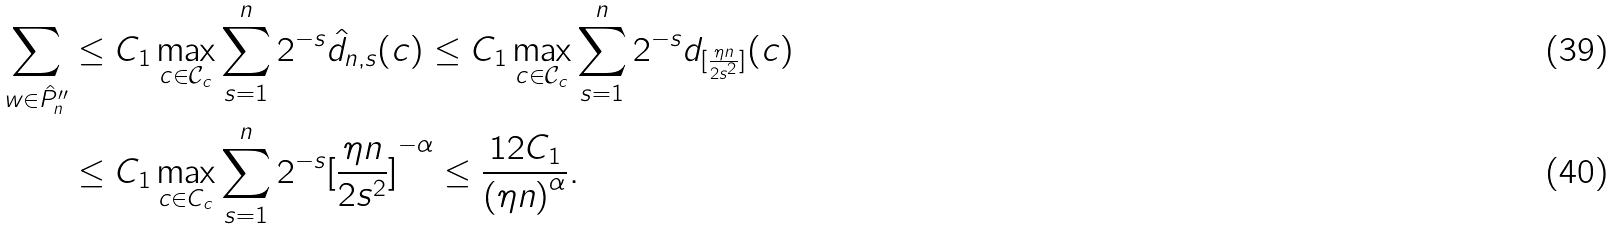<formula> <loc_0><loc_0><loc_500><loc_500>\sum _ { w \in \hat { P } _ { n } ^ { \prime \prime } } & \leq C _ { 1 } \max _ { c \in \mathcal { C } _ { c } } \sum _ { s = 1 } ^ { n } 2 ^ { - s } \hat { d } _ { n , s } ( c ) \leq C _ { 1 } \max _ { c \in \mathcal { C } _ { c } } \sum _ { s = 1 } ^ { n } 2 ^ { - s } d _ { [ \frac { \eta n } { 2 s ^ { 2 } } ] } ( c ) \\ & \leq C _ { 1 } \max _ { c \in C _ { c } } \sum _ { s = 1 } ^ { n } 2 ^ { - s } { [ \frac { \eta n } { 2 s ^ { 2 } } ] } ^ { - \alpha } \leq \frac { 1 2 C _ { 1 } } { { ( \eta n ) } ^ { \alpha } } .</formula> 